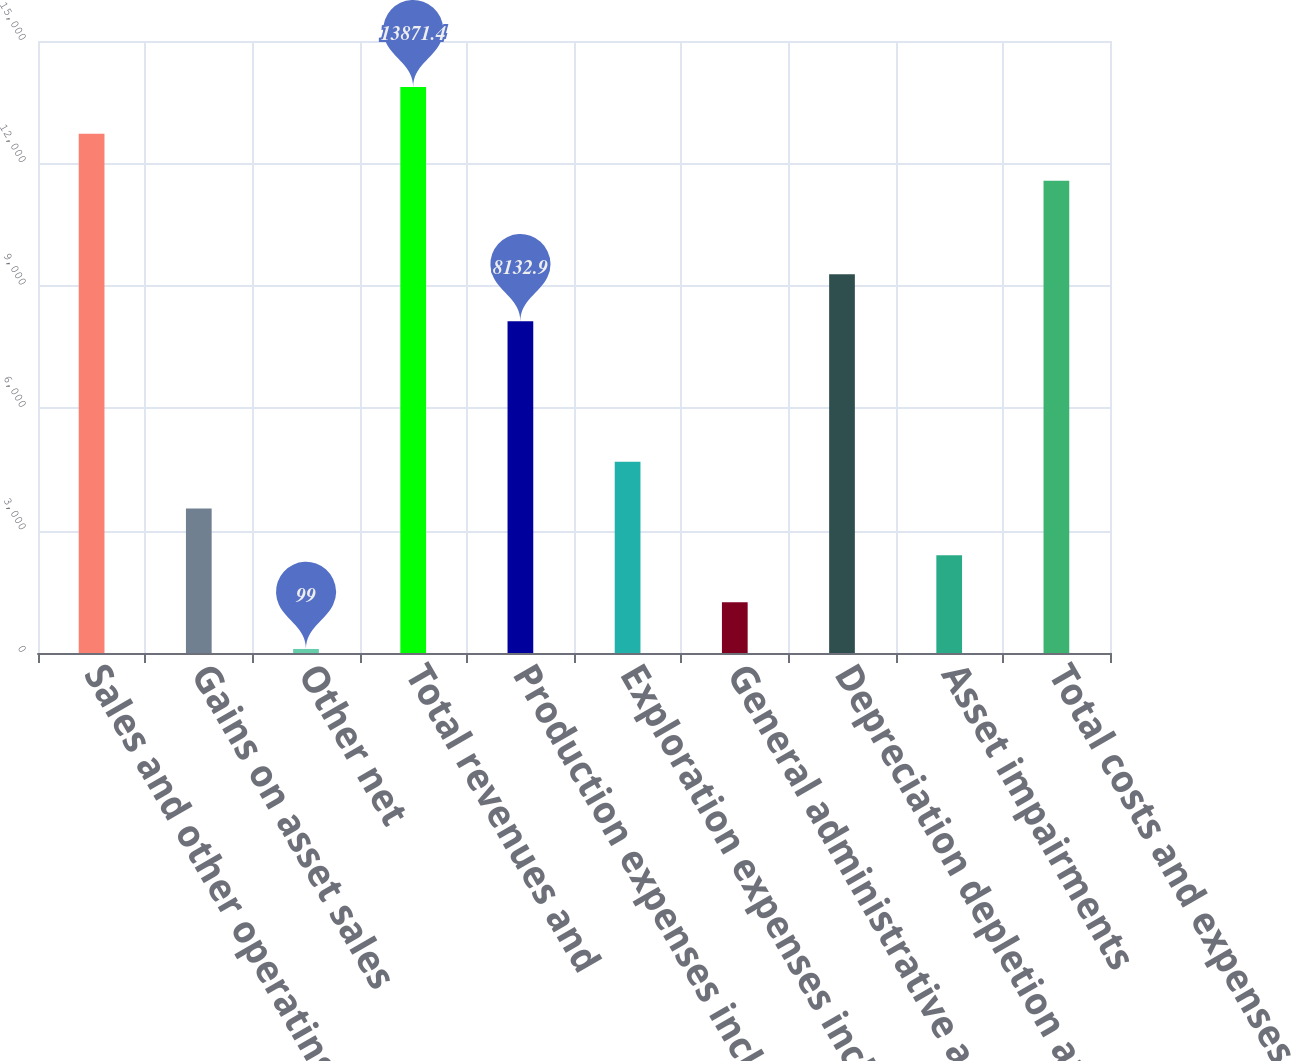<chart> <loc_0><loc_0><loc_500><loc_500><bar_chart><fcel>Sales and other operating<fcel>Gains on asset sales<fcel>Other net<fcel>Total revenues and<fcel>Production expenses including<fcel>Exploration expenses including<fcel>General administrative and<fcel>Depreciation depletion and<fcel>Asset impairments<fcel>Total costs and expenses<nl><fcel>12723.7<fcel>3542.1<fcel>99<fcel>13871.4<fcel>8132.9<fcel>4689.8<fcel>1246.7<fcel>9280.6<fcel>2394.4<fcel>11576<nl></chart> 